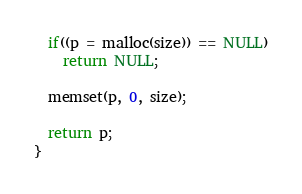<code> <loc_0><loc_0><loc_500><loc_500><_C_>
  if((p = malloc(size)) == NULL)
    return NULL;

  memset(p, 0, size);

  return p;
}
</code> 